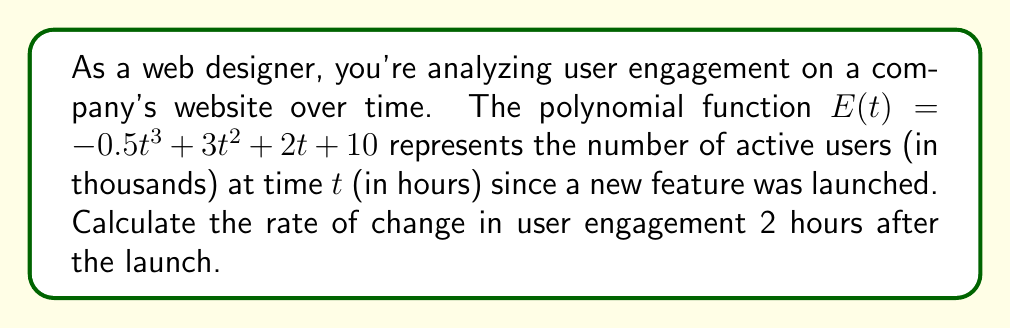Solve this math problem. To solve this problem, we need to follow these steps:

1) The rate of change in user engagement is represented by the derivative of the function $E(t)$.

2) Let's find the derivative of $E(t)$:
   $$E'(t) = \frac{d}{dt}(-0.5t^3 + 3t^2 + 2t + 10)$$
   $$E'(t) = -1.5t^2 + 6t + 2$$

3) Now that we have the rate of change function, we need to evaluate it at $t = 2$ hours:
   $$E'(2) = -1.5(2)^2 + 6(2) + 2$$
   $$E'(2) = -1.5(4) + 12 + 2$$
   $$E'(2) = -6 + 12 + 2$$
   $$E'(2) = 8$$

4) The units of the result are in thousands of users per hour, as the original function was in thousands of users and time was in hours.
Answer: The rate of change in user engagement 2 hours after the launch is 8,000 users per hour. 